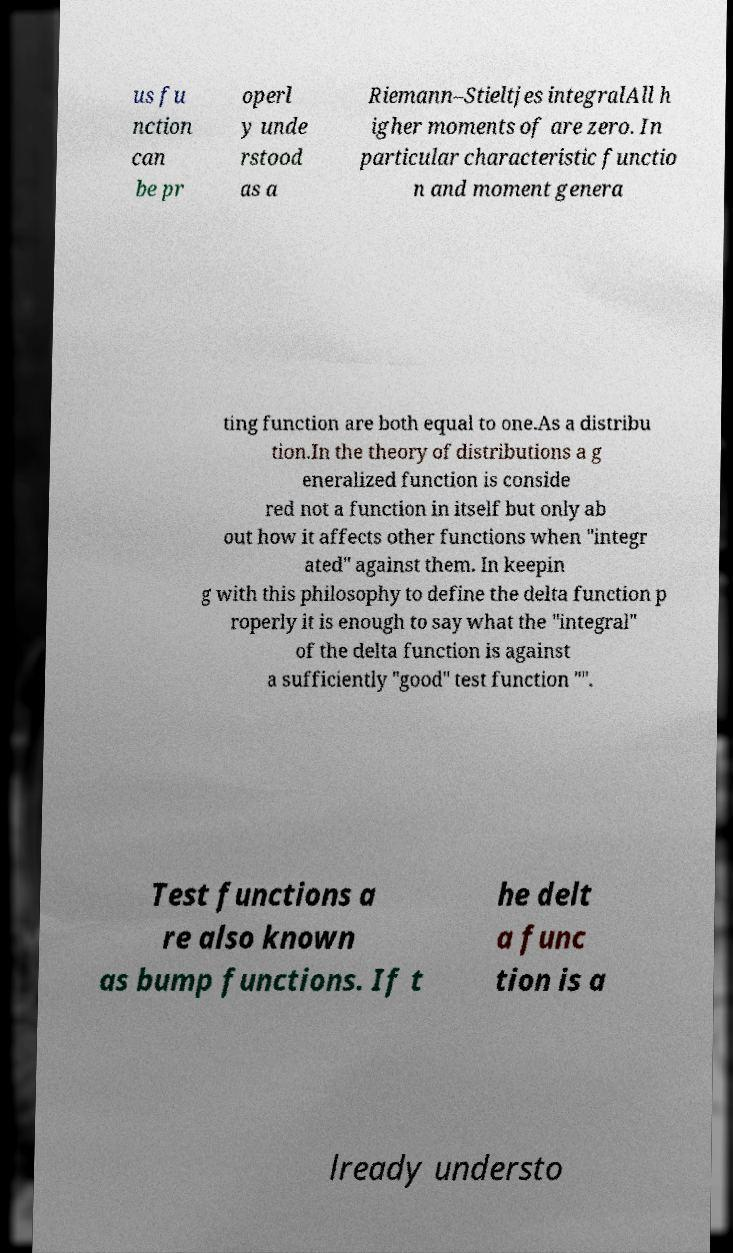Can you accurately transcribe the text from the provided image for me? us fu nction can be pr operl y unde rstood as a Riemann–Stieltjes integralAll h igher moments of are zero. In particular characteristic functio n and moment genera ting function are both equal to one.As a distribu tion.In the theory of distributions a g eneralized function is conside red not a function in itself but only ab out how it affects other functions when "integr ated" against them. In keepin g with this philosophy to define the delta function p roperly it is enough to say what the "integral" of the delta function is against a sufficiently "good" test function "". Test functions a re also known as bump functions. If t he delt a func tion is a lready understo 